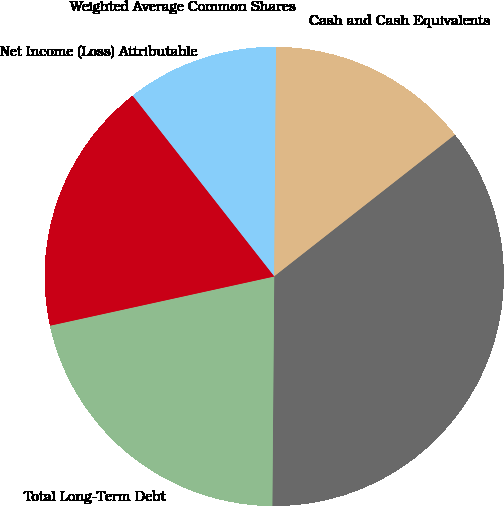Convert chart. <chart><loc_0><loc_0><loc_500><loc_500><pie_chart><fcel>Net Income (Loss) Attributable<fcel>Weighted Average Common Shares<fcel>Cash and Cash Equivalents<fcel>Total Assets<fcel>Total Long-Term Debt<fcel>Total Equity<nl><fcel>0.0%<fcel>10.71%<fcel>14.29%<fcel>35.71%<fcel>21.43%<fcel>17.86%<nl></chart> 